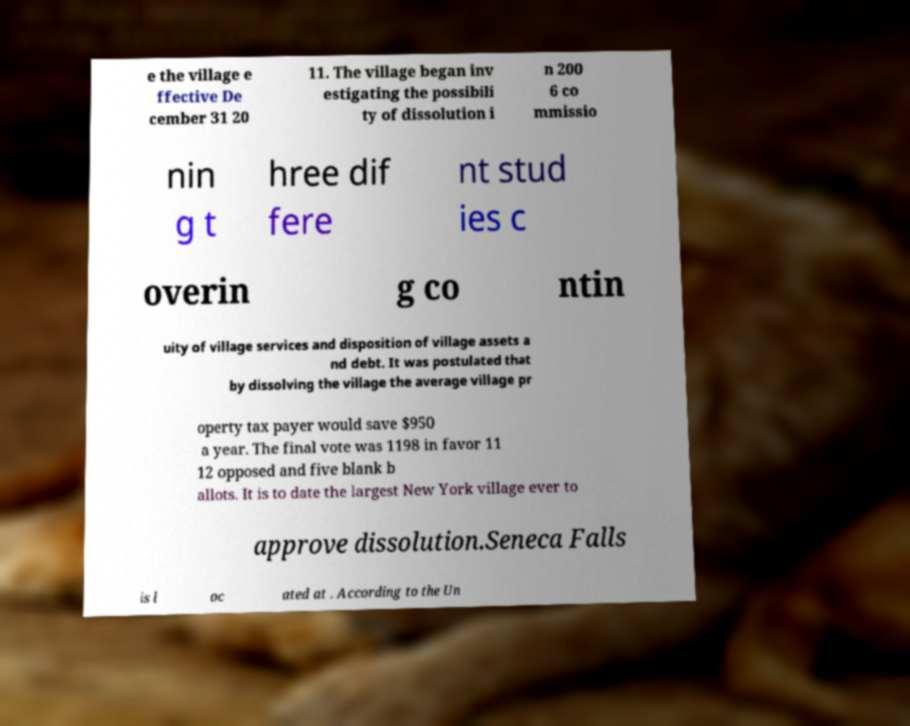Please read and relay the text visible in this image. What does it say? e the village e ffective De cember 31 20 11. The village began inv estigating the possibili ty of dissolution i n 200 6 co mmissio nin g t hree dif fere nt stud ies c overin g co ntin uity of village services and disposition of village assets a nd debt. It was postulated that by dissolving the village the average village pr operty tax payer would save $950 a year. The final vote was 1198 in favor 11 12 opposed and five blank b allots. It is to date the largest New York village ever to approve dissolution.Seneca Falls is l oc ated at . According to the Un 